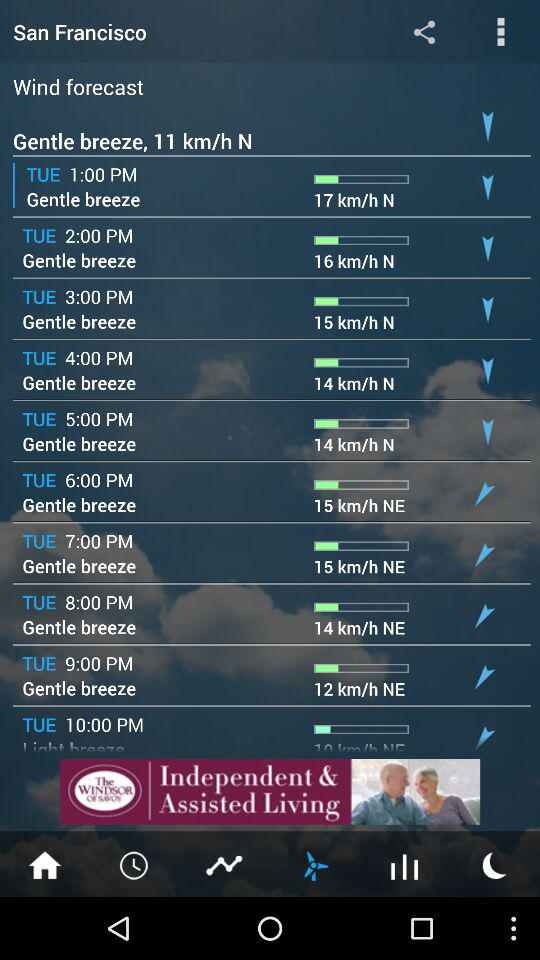What is the speed of the breeze on Tuesday at 1:00 PM? The speed of the breeze on Tuesday at 1:00 PM is 17 km/h. 